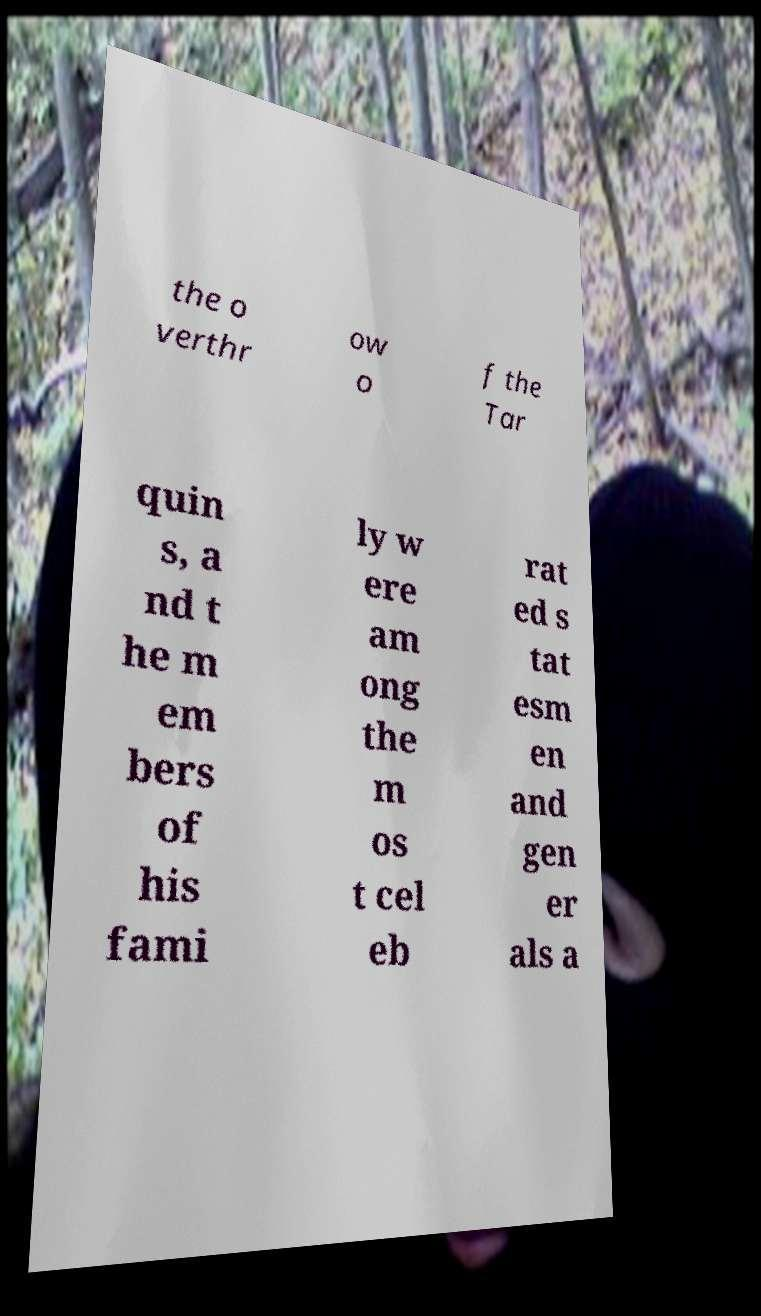There's text embedded in this image that I need extracted. Can you transcribe it verbatim? the o verthr ow o f the Tar quin s, a nd t he m em bers of his fami ly w ere am ong the m os t cel eb rat ed s tat esm en and gen er als a 